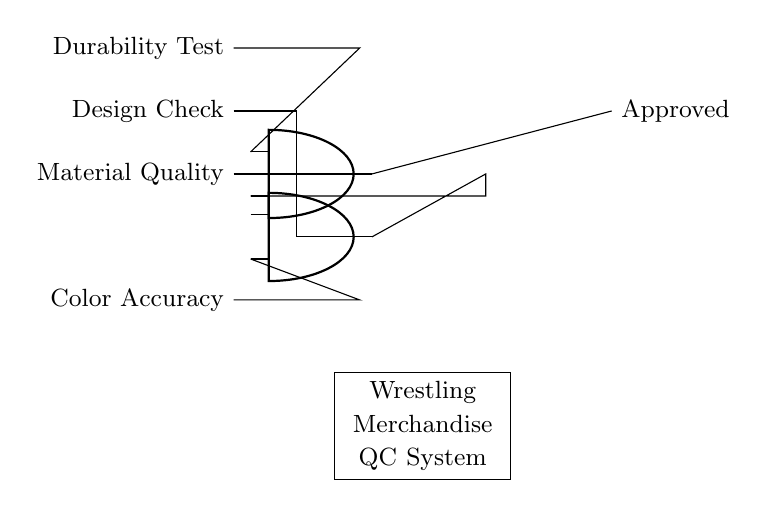What are the inputs to the AND gate? The inputs to the AND gate are "Material Quality" and the output from the lower AND gate. The lower AND gate takes "Design Check" and "Color Accuracy" as its inputs.
Answer: Material Quality and Design Check, Color Accuracy What is the output of the AND gate? The output of the AND gate labeled "Approved" represents the final quality check, indicating whether all required criteria are met together by the inputs.
Answer: Approved How many AND gates are present in this circuit? There are two AND gates in this circuit. One AND gate is positioned at the top, and the other is at the bottom of the diagram.
Answer: Two What is required for the merchandise to be approved? For the merchandise to be approved, all input conditions must be met, meaning each of the four criteria: "Material Quality," "Durability Test," "Design Check," and "Color Accuracy" must be satisfied.
Answer: All criteria What do both AND gates represent in the context of quality control? Both AND gates represent a logical requirement that all specified conditions must be satisfied to ensure quality control in wrestling merchandise production.
Answer: Logical requirements What are the two inputs to the lower AND gate? The two inputs to the lower AND gate are "Design Check" and "Color Accuracy," which must also be satisfied to contribute to the final approval of the product.
Answer: Design Check and Color Accuracy 